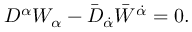<formula> <loc_0><loc_0><loc_500><loc_500>D ^ { \alpha } W _ { \alpha } - \bar { D } _ { \dot { \alpha } } \bar { W } ^ { \dot { \alpha } } = 0 .</formula> 